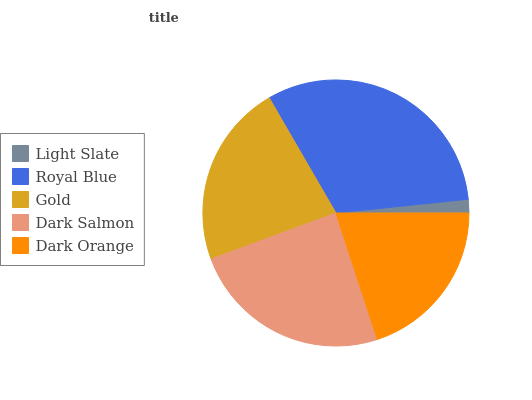Is Light Slate the minimum?
Answer yes or no. Yes. Is Royal Blue the maximum?
Answer yes or no. Yes. Is Gold the minimum?
Answer yes or no. No. Is Gold the maximum?
Answer yes or no. No. Is Royal Blue greater than Gold?
Answer yes or no. Yes. Is Gold less than Royal Blue?
Answer yes or no. Yes. Is Gold greater than Royal Blue?
Answer yes or no. No. Is Royal Blue less than Gold?
Answer yes or no. No. Is Gold the high median?
Answer yes or no. Yes. Is Gold the low median?
Answer yes or no. Yes. Is Dark Orange the high median?
Answer yes or no. No. Is Royal Blue the low median?
Answer yes or no. No. 